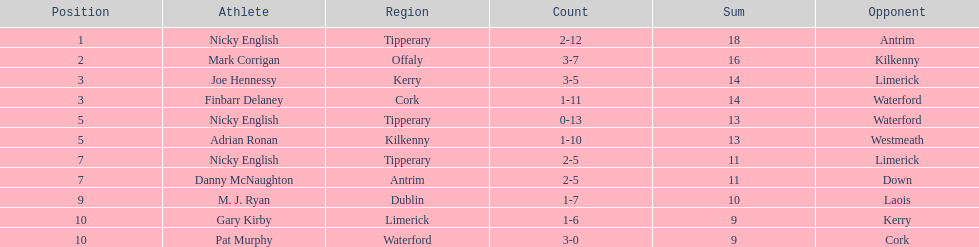What is the first name on the list? Nicky English. 